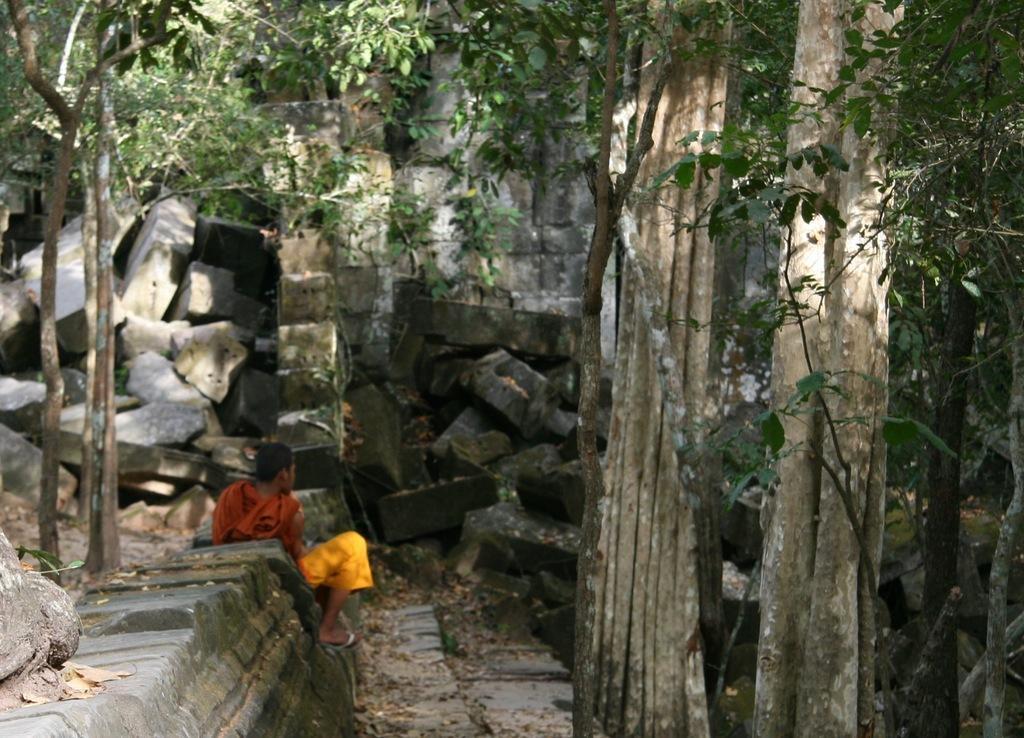Can you describe this image briefly? In the image I can a person who is sitting on the rock and also I can see some other rocks, trees and plants. 